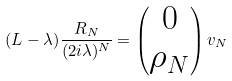Convert formula to latex. <formula><loc_0><loc_0><loc_500><loc_500>( L - \lambda ) \frac { R _ { N } } { ( 2 i \lambda ) ^ { N } } = \begin{pmatrix} 0 \\ \rho _ { N } \end{pmatrix} v _ { N }</formula> 